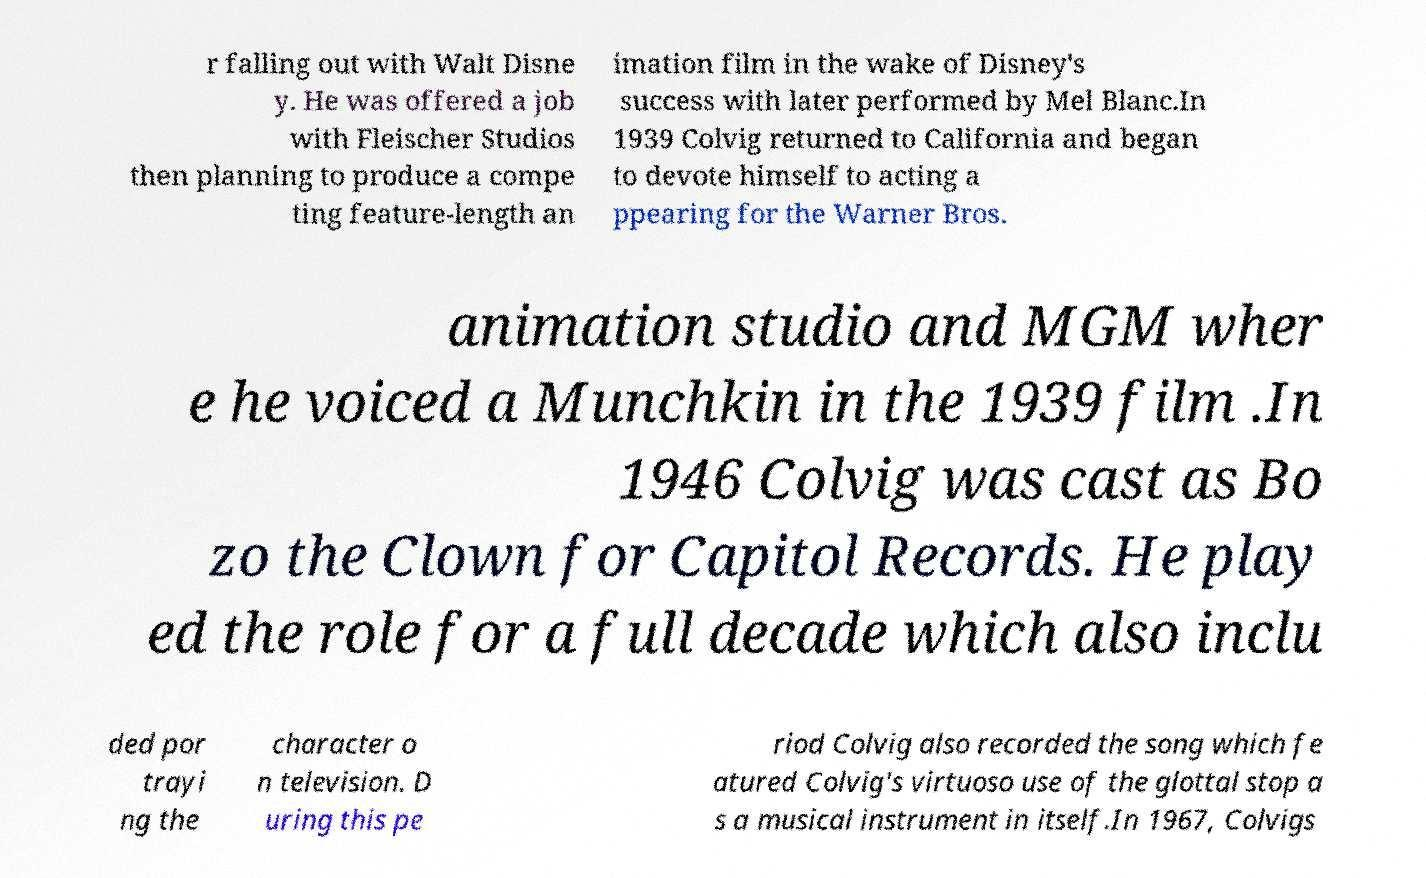For documentation purposes, I need the text within this image transcribed. Could you provide that? r falling out with Walt Disne y. He was offered a job with Fleischer Studios then planning to produce a compe ting feature-length an imation film in the wake of Disney's success with later performed by Mel Blanc.In 1939 Colvig returned to California and began to devote himself to acting a ppearing for the Warner Bros. animation studio and MGM wher e he voiced a Munchkin in the 1939 film .In 1946 Colvig was cast as Bo zo the Clown for Capitol Records. He play ed the role for a full decade which also inclu ded por trayi ng the character o n television. D uring this pe riod Colvig also recorded the song which fe atured Colvig's virtuoso use of the glottal stop a s a musical instrument in itself.In 1967, Colvigs 